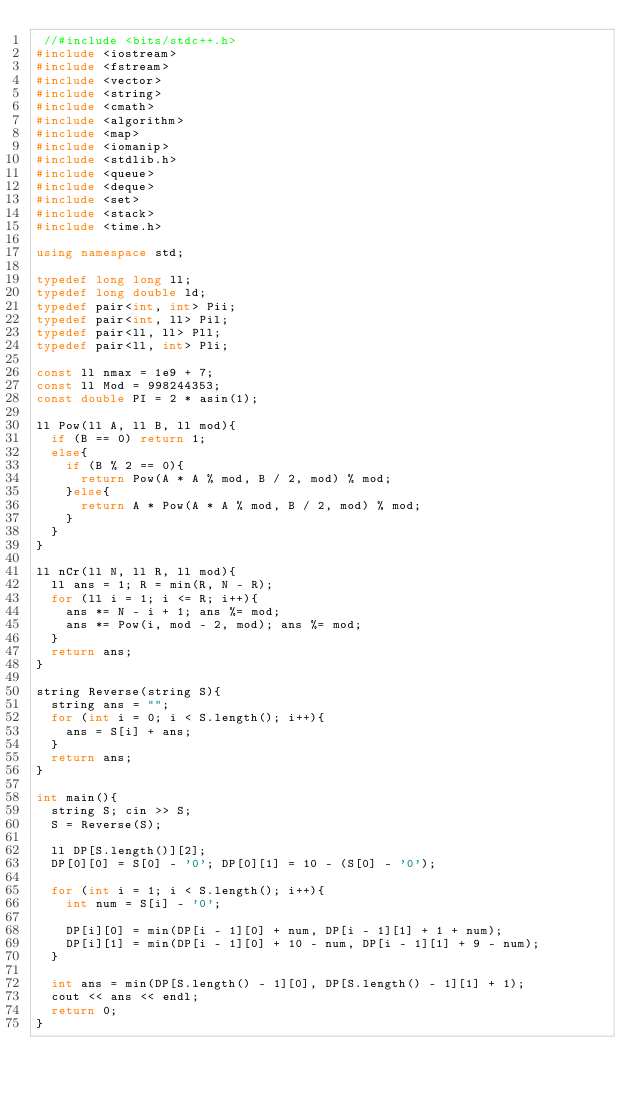<code> <loc_0><loc_0><loc_500><loc_500><_C++_> //#include <bits/stdc++.h>
#include <iostream>
#include <fstream>
#include <vector>
#include <string>
#include <cmath>
#include <algorithm>
#include <map>
#include <iomanip>
#include <stdlib.h>
#include <queue>
#include <deque>
#include <set>
#include <stack>
#include <time.h>
 
using namespace std;
 
typedef long long ll;
typedef long double ld;
typedef pair<int, int> Pii;
typedef pair<int, ll> Pil;
typedef pair<ll, ll> Pll;
typedef pair<ll, int> Pli;

const ll nmax = 1e9 + 7;
const ll Mod = 998244353;
const double PI = 2 * asin(1);

ll Pow(ll A, ll B, ll mod){
  if (B == 0) return 1;
  else{
    if (B % 2 == 0){
      return Pow(A * A % mod, B / 2, mod) % mod;
    }else{
      return A * Pow(A * A % mod, B / 2, mod) % mod;
    }
  }
}

ll nCr(ll N, ll R, ll mod){
  ll ans = 1; R = min(R, N - R);
  for (ll i = 1; i <= R; i++){
    ans *= N - i + 1; ans %= mod;
    ans *= Pow(i, mod - 2, mod); ans %= mod;
  }
  return ans;
}

string Reverse(string S){
  string ans = "";
  for (int i = 0; i < S.length(); i++){
    ans = S[i] + ans;
  }
  return ans;
}

int main(){
  string S; cin >> S;
  S = Reverse(S);
  
  ll DP[S.length()][2];
  DP[0][0] = S[0] - '0'; DP[0][1] = 10 - (S[0] - '0');

  for (int i = 1; i < S.length(); i++){
    int num = S[i] - '0';

    DP[i][0] = min(DP[i - 1][0] + num, DP[i - 1][1] + 1 + num);
    DP[i][1] = min(DP[i - 1][0] + 10 - num, DP[i - 1][1] + 9 - num);
  }
  
  int ans = min(DP[S.length() - 1][0], DP[S.length() - 1][1] + 1);
  cout << ans << endl;
  return 0;
}
</code> 